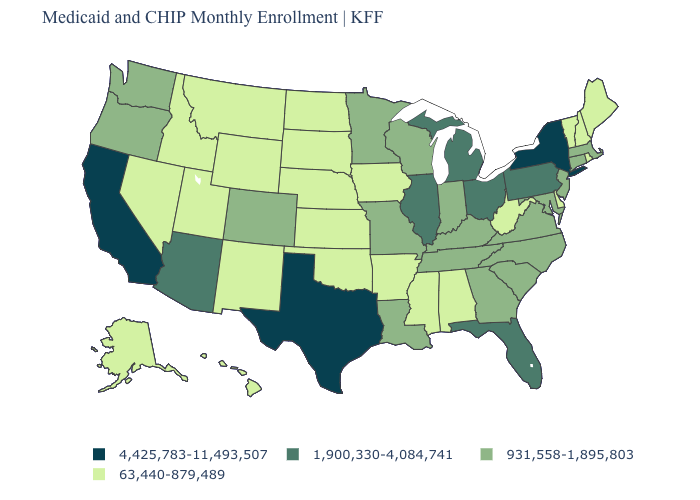Among the states that border South Dakota , which have the lowest value?
Give a very brief answer. Iowa, Montana, Nebraska, North Dakota, Wyoming. What is the value of Tennessee?
Short answer required. 931,558-1,895,803. Does the first symbol in the legend represent the smallest category?
Give a very brief answer. No. How many symbols are there in the legend?
Quick response, please. 4. What is the value of Arkansas?
Answer briefly. 63,440-879,489. What is the value of New Jersey?
Write a very short answer. 931,558-1,895,803. What is the highest value in the USA?
Be succinct. 4,425,783-11,493,507. What is the highest value in the USA?
Write a very short answer. 4,425,783-11,493,507. What is the lowest value in the West?
Write a very short answer. 63,440-879,489. Does New York have the highest value in the Northeast?
Keep it brief. Yes. Does the map have missing data?
Concise answer only. No. Name the states that have a value in the range 4,425,783-11,493,507?
Write a very short answer. California, New York, Texas. Does the first symbol in the legend represent the smallest category?
Keep it brief. No. Name the states that have a value in the range 931,558-1,895,803?
Keep it brief. Colorado, Connecticut, Georgia, Indiana, Kentucky, Louisiana, Maryland, Massachusetts, Minnesota, Missouri, New Jersey, North Carolina, Oregon, South Carolina, Tennessee, Virginia, Washington, Wisconsin. Which states have the highest value in the USA?
Short answer required. California, New York, Texas. 